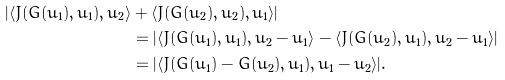Convert formula to latex. <formula><loc_0><loc_0><loc_500><loc_500>| \langle J ( G ( u _ { 1 } ) , u _ { 1 } ) , u _ { 2 } \rangle & + \langle J ( G ( u _ { 2 } ) , u _ { 2 } ) , u _ { 1 } \rangle | \\ & = | \langle J ( G ( u _ { 1 } ) , u _ { 1 } ) , u _ { 2 } - u _ { 1 } \rangle - \langle J ( G ( u _ { 2 } ) , u _ { 1 } ) , u _ { 2 } - u _ { 1 } \rangle | \\ & = | \langle J ( G ( u _ { 1 } ) - G ( u _ { 2 } ) , u _ { 1 } ) , u _ { 1 } - u _ { 2 } \rangle | .</formula> 